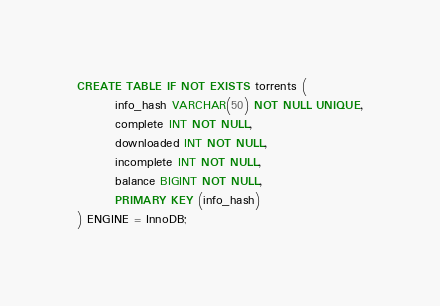Convert code to text. <code><loc_0><loc_0><loc_500><loc_500><_SQL_>CREATE TABLE IF NOT EXISTS torrents (
        info_hash VARCHAR(50) NOT NULL UNIQUE,
        complete INT NOT NULL,
        downloaded INT NOT NULL,
        incomplete INT NOT NULL,
        balance BIGINT NOT NULL,
        PRIMARY KEY (info_hash)
) ENGINE = InnoDB;
</code> 